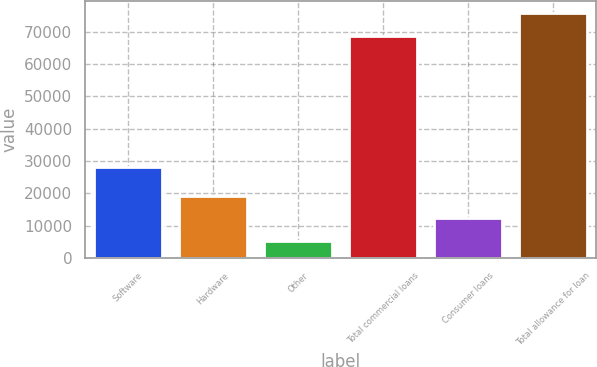Convert chart to OTSL. <chart><loc_0><loc_0><loc_500><loc_500><bar_chart><fcel>Software<fcel>Hardware<fcel>Other<fcel>Total commercial loans<fcel>Consumer loans<fcel>Total allowance for loan<nl><fcel>28302<fcel>19295<fcel>5196<fcel>68864<fcel>12245.5<fcel>75913.5<nl></chart> 